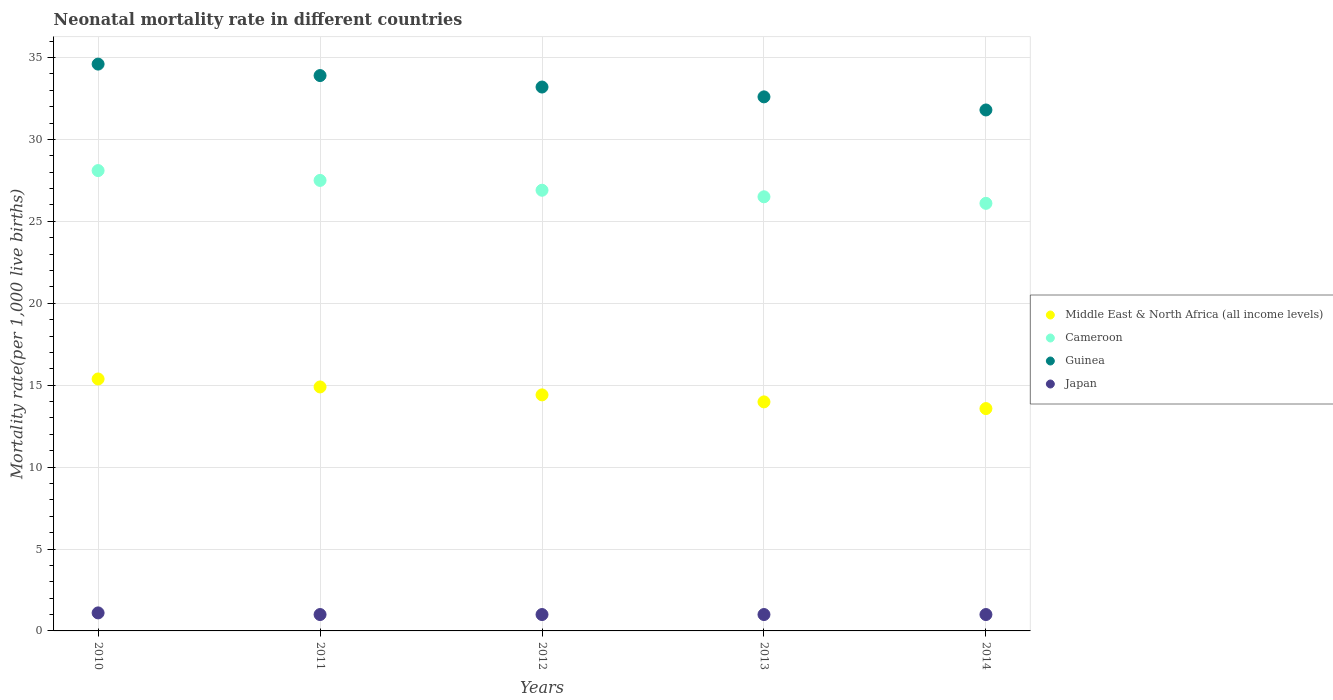Is the number of dotlines equal to the number of legend labels?
Offer a terse response. Yes. What is the neonatal mortality rate in Cameroon in 2010?
Provide a short and direct response. 28.1. Across all years, what is the maximum neonatal mortality rate in Cameroon?
Provide a succinct answer. 28.1. Across all years, what is the minimum neonatal mortality rate in Middle East & North Africa (all income levels)?
Your answer should be compact. 13.57. In which year was the neonatal mortality rate in Guinea minimum?
Give a very brief answer. 2014. What is the total neonatal mortality rate in Guinea in the graph?
Offer a very short reply. 166.1. What is the difference between the neonatal mortality rate in Guinea in 2010 and that in 2012?
Ensure brevity in your answer.  1.4. What is the difference between the neonatal mortality rate in Cameroon in 2014 and the neonatal mortality rate in Middle East & North Africa (all income levels) in 2010?
Your response must be concise. 10.72. What is the average neonatal mortality rate in Guinea per year?
Provide a succinct answer. 33.22. In the year 2011, what is the difference between the neonatal mortality rate in Japan and neonatal mortality rate in Cameroon?
Offer a very short reply. -26.5. What is the ratio of the neonatal mortality rate in Cameroon in 2010 to that in 2011?
Provide a short and direct response. 1.02. Is the neonatal mortality rate in Japan in 2011 less than that in 2013?
Your answer should be compact. No. What is the difference between the highest and the second highest neonatal mortality rate in Cameroon?
Ensure brevity in your answer.  0.6. What is the difference between the highest and the lowest neonatal mortality rate in Japan?
Your answer should be compact. 0.1. In how many years, is the neonatal mortality rate in Middle East & North Africa (all income levels) greater than the average neonatal mortality rate in Middle East & North Africa (all income levels) taken over all years?
Offer a very short reply. 2. Is the sum of the neonatal mortality rate in Guinea in 2010 and 2011 greater than the maximum neonatal mortality rate in Japan across all years?
Give a very brief answer. Yes. Is it the case that in every year, the sum of the neonatal mortality rate in Japan and neonatal mortality rate in Guinea  is greater than the sum of neonatal mortality rate in Cameroon and neonatal mortality rate in Middle East & North Africa (all income levels)?
Keep it short and to the point. No. Is it the case that in every year, the sum of the neonatal mortality rate in Guinea and neonatal mortality rate in Japan  is greater than the neonatal mortality rate in Cameroon?
Ensure brevity in your answer.  Yes. How many years are there in the graph?
Give a very brief answer. 5. What is the difference between two consecutive major ticks on the Y-axis?
Your answer should be compact. 5. Are the values on the major ticks of Y-axis written in scientific E-notation?
Your answer should be compact. No. Does the graph contain any zero values?
Your answer should be very brief. No. Where does the legend appear in the graph?
Offer a very short reply. Center right. What is the title of the graph?
Offer a very short reply. Neonatal mortality rate in different countries. What is the label or title of the X-axis?
Give a very brief answer. Years. What is the label or title of the Y-axis?
Your answer should be compact. Mortality rate(per 1,0 live births). What is the Mortality rate(per 1,000 live births) of Middle East & North Africa (all income levels) in 2010?
Your answer should be compact. 15.38. What is the Mortality rate(per 1,000 live births) of Cameroon in 2010?
Keep it short and to the point. 28.1. What is the Mortality rate(per 1,000 live births) in Guinea in 2010?
Offer a terse response. 34.6. What is the Mortality rate(per 1,000 live births) of Japan in 2010?
Give a very brief answer. 1.1. What is the Mortality rate(per 1,000 live births) in Middle East & North Africa (all income levels) in 2011?
Provide a short and direct response. 14.89. What is the Mortality rate(per 1,000 live births) of Cameroon in 2011?
Give a very brief answer. 27.5. What is the Mortality rate(per 1,000 live births) in Guinea in 2011?
Provide a short and direct response. 33.9. What is the Mortality rate(per 1,000 live births) in Middle East & North Africa (all income levels) in 2012?
Make the answer very short. 14.41. What is the Mortality rate(per 1,000 live births) of Cameroon in 2012?
Offer a very short reply. 26.9. What is the Mortality rate(per 1,000 live births) of Guinea in 2012?
Offer a terse response. 33.2. What is the Mortality rate(per 1,000 live births) of Japan in 2012?
Keep it short and to the point. 1. What is the Mortality rate(per 1,000 live births) in Middle East & North Africa (all income levels) in 2013?
Keep it short and to the point. 13.98. What is the Mortality rate(per 1,000 live births) of Cameroon in 2013?
Make the answer very short. 26.5. What is the Mortality rate(per 1,000 live births) of Guinea in 2013?
Ensure brevity in your answer.  32.6. What is the Mortality rate(per 1,000 live births) in Middle East & North Africa (all income levels) in 2014?
Give a very brief answer. 13.57. What is the Mortality rate(per 1,000 live births) of Cameroon in 2014?
Make the answer very short. 26.1. What is the Mortality rate(per 1,000 live births) in Guinea in 2014?
Offer a very short reply. 31.8. Across all years, what is the maximum Mortality rate(per 1,000 live births) of Middle East & North Africa (all income levels)?
Your answer should be very brief. 15.38. Across all years, what is the maximum Mortality rate(per 1,000 live births) of Cameroon?
Offer a terse response. 28.1. Across all years, what is the maximum Mortality rate(per 1,000 live births) in Guinea?
Your answer should be compact. 34.6. Across all years, what is the minimum Mortality rate(per 1,000 live births) in Middle East & North Africa (all income levels)?
Offer a very short reply. 13.57. Across all years, what is the minimum Mortality rate(per 1,000 live births) in Cameroon?
Offer a very short reply. 26.1. Across all years, what is the minimum Mortality rate(per 1,000 live births) in Guinea?
Offer a very short reply. 31.8. What is the total Mortality rate(per 1,000 live births) in Middle East & North Africa (all income levels) in the graph?
Provide a short and direct response. 72.23. What is the total Mortality rate(per 1,000 live births) of Cameroon in the graph?
Make the answer very short. 135.1. What is the total Mortality rate(per 1,000 live births) in Guinea in the graph?
Your answer should be very brief. 166.1. What is the difference between the Mortality rate(per 1,000 live births) in Middle East & North Africa (all income levels) in 2010 and that in 2011?
Provide a short and direct response. 0.49. What is the difference between the Mortality rate(per 1,000 live births) of Japan in 2010 and that in 2011?
Make the answer very short. 0.1. What is the difference between the Mortality rate(per 1,000 live births) of Middle East & North Africa (all income levels) in 2010 and that in 2012?
Your answer should be compact. 0.97. What is the difference between the Mortality rate(per 1,000 live births) in Japan in 2010 and that in 2012?
Ensure brevity in your answer.  0.1. What is the difference between the Mortality rate(per 1,000 live births) in Middle East & North Africa (all income levels) in 2010 and that in 2013?
Ensure brevity in your answer.  1.4. What is the difference between the Mortality rate(per 1,000 live births) of Japan in 2010 and that in 2013?
Your response must be concise. 0.1. What is the difference between the Mortality rate(per 1,000 live births) in Middle East & North Africa (all income levels) in 2010 and that in 2014?
Ensure brevity in your answer.  1.81. What is the difference between the Mortality rate(per 1,000 live births) in Cameroon in 2010 and that in 2014?
Provide a succinct answer. 2. What is the difference between the Mortality rate(per 1,000 live births) of Middle East & North Africa (all income levels) in 2011 and that in 2012?
Ensure brevity in your answer.  0.48. What is the difference between the Mortality rate(per 1,000 live births) in Guinea in 2011 and that in 2012?
Give a very brief answer. 0.7. What is the difference between the Mortality rate(per 1,000 live births) in Japan in 2011 and that in 2012?
Provide a succinct answer. 0. What is the difference between the Mortality rate(per 1,000 live births) of Middle East & North Africa (all income levels) in 2011 and that in 2013?
Your answer should be compact. 0.91. What is the difference between the Mortality rate(per 1,000 live births) in Guinea in 2011 and that in 2013?
Give a very brief answer. 1.3. What is the difference between the Mortality rate(per 1,000 live births) in Middle East & North Africa (all income levels) in 2011 and that in 2014?
Your answer should be compact. 1.32. What is the difference between the Mortality rate(per 1,000 live births) in Cameroon in 2011 and that in 2014?
Your answer should be compact. 1.4. What is the difference between the Mortality rate(per 1,000 live births) in Japan in 2011 and that in 2014?
Offer a terse response. 0. What is the difference between the Mortality rate(per 1,000 live births) of Middle East & North Africa (all income levels) in 2012 and that in 2013?
Keep it short and to the point. 0.43. What is the difference between the Mortality rate(per 1,000 live births) of Guinea in 2012 and that in 2013?
Your response must be concise. 0.6. What is the difference between the Mortality rate(per 1,000 live births) in Middle East & North Africa (all income levels) in 2012 and that in 2014?
Make the answer very short. 0.84. What is the difference between the Mortality rate(per 1,000 live births) in Guinea in 2012 and that in 2014?
Your answer should be very brief. 1.4. What is the difference between the Mortality rate(per 1,000 live births) of Middle East & North Africa (all income levels) in 2013 and that in 2014?
Your answer should be very brief. 0.41. What is the difference between the Mortality rate(per 1,000 live births) in Japan in 2013 and that in 2014?
Your answer should be compact. 0. What is the difference between the Mortality rate(per 1,000 live births) of Middle East & North Africa (all income levels) in 2010 and the Mortality rate(per 1,000 live births) of Cameroon in 2011?
Your response must be concise. -12.12. What is the difference between the Mortality rate(per 1,000 live births) of Middle East & North Africa (all income levels) in 2010 and the Mortality rate(per 1,000 live births) of Guinea in 2011?
Your response must be concise. -18.52. What is the difference between the Mortality rate(per 1,000 live births) in Middle East & North Africa (all income levels) in 2010 and the Mortality rate(per 1,000 live births) in Japan in 2011?
Your answer should be very brief. 14.38. What is the difference between the Mortality rate(per 1,000 live births) in Cameroon in 2010 and the Mortality rate(per 1,000 live births) in Japan in 2011?
Your answer should be very brief. 27.1. What is the difference between the Mortality rate(per 1,000 live births) in Guinea in 2010 and the Mortality rate(per 1,000 live births) in Japan in 2011?
Keep it short and to the point. 33.6. What is the difference between the Mortality rate(per 1,000 live births) in Middle East & North Africa (all income levels) in 2010 and the Mortality rate(per 1,000 live births) in Cameroon in 2012?
Your answer should be compact. -11.52. What is the difference between the Mortality rate(per 1,000 live births) of Middle East & North Africa (all income levels) in 2010 and the Mortality rate(per 1,000 live births) of Guinea in 2012?
Offer a very short reply. -17.82. What is the difference between the Mortality rate(per 1,000 live births) of Middle East & North Africa (all income levels) in 2010 and the Mortality rate(per 1,000 live births) of Japan in 2012?
Offer a terse response. 14.38. What is the difference between the Mortality rate(per 1,000 live births) in Cameroon in 2010 and the Mortality rate(per 1,000 live births) in Japan in 2012?
Ensure brevity in your answer.  27.1. What is the difference between the Mortality rate(per 1,000 live births) in Guinea in 2010 and the Mortality rate(per 1,000 live births) in Japan in 2012?
Your answer should be compact. 33.6. What is the difference between the Mortality rate(per 1,000 live births) of Middle East & North Africa (all income levels) in 2010 and the Mortality rate(per 1,000 live births) of Cameroon in 2013?
Provide a short and direct response. -11.12. What is the difference between the Mortality rate(per 1,000 live births) in Middle East & North Africa (all income levels) in 2010 and the Mortality rate(per 1,000 live births) in Guinea in 2013?
Your answer should be very brief. -17.22. What is the difference between the Mortality rate(per 1,000 live births) of Middle East & North Africa (all income levels) in 2010 and the Mortality rate(per 1,000 live births) of Japan in 2013?
Make the answer very short. 14.38. What is the difference between the Mortality rate(per 1,000 live births) of Cameroon in 2010 and the Mortality rate(per 1,000 live births) of Guinea in 2013?
Offer a very short reply. -4.5. What is the difference between the Mortality rate(per 1,000 live births) in Cameroon in 2010 and the Mortality rate(per 1,000 live births) in Japan in 2013?
Give a very brief answer. 27.1. What is the difference between the Mortality rate(per 1,000 live births) of Guinea in 2010 and the Mortality rate(per 1,000 live births) of Japan in 2013?
Offer a terse response. 33.6. What is the difference between the Mortality rate(per 1,000 live births) in Middle East & North Africa (all income levels) in 2010 and the Mortality rate(per 1,000 live births) in Cameroon in 2014?
Make the answer very short. -10.72. What is the difference between the Mortality rate(per 1,000 live births) in Middle East & North Africa (all income levels) in 2010 and the Mortality rate(per 1,000 live births) in Guinea in 2014?
Offer a terse response. -16.42. What is the difference between the Mortality rate(per 1,000 live births) in Middle East & North Africa (all income levels) in 2010 and the Mortality rate(per 1,000 live births) in Japan in 2014?
Your answer should be very brief. 14.38. What is the difference between the Mortality rate(per 1,000 live births) of Cameroon in 2010 and the Mortality rate(per 1,000 live births) of Japan in 2014?
Keep it short and to the point. 27.1. What is the difference between the Mortality rate(per 1,000 live births) in Guinea in 2010 and the Mortality rate(per 1,000 live births) in Japan in 2014?
Keep it short and to the point. 33.6. What is the difference between the Mortality rate(per 1,000 live births) of Middle East & North Africa (all income levels) in 2011 and the Mortality rate(per 1,000 live births) of Cameroon in 2012?
Make the answer very short. -12.01. What is the difference between the Mortality rate(per 1,000 live births) in Middle East & North Africa (all income levels) in 2011 and the Mortality rate(per 1,000 live births) in Guinea in 2012?
Make the answer very short. -18.31. What is the difference between the Mortality rate(per 1,000 live births) in Middle East & North Africa (all income levels) in 2011 and the Mortality rate(per 1,000 live births) in Japan in 2012?
Give a very brief answer. 13.89. What is the difference between the Mortality rate(per 1,000 live births) of Cameroon in 2011 and the Mortality rate(per 1,000 live births) of Japan in 2012?
Ensure brevity in your answer.  26.5. What is the difference between the Mortality rate(per 1,000 live births) in Guinea in 2011 and the Mortality rate(per 1,000 live births) in Japan in 2012?
Offer a very short reply. 32.9. What is the difference between the Mortality rate(per 1,000 live births) in Middle East & North Africa (all income levels) in 2011 and the Mortality rate(per 1,000 live births) in Cameroon in 2013?
Offer a terse response. -11.61. What is the difference between the Mortality rate(per 1,000 live births) of Middle East & North Africa (all income levels) in 2011 and the Mortality rate(per 1,000 live births) of Guinea in 2013?
Provide a short and direct response. -17.71. What is the difference between the Mortality rate(per 1,000 live births) of Middle East & North Africa (all income levels) in 2011 and the Mortality rate(per 1,000 live births) of Japan in 2013?
Make the answer very short. 13.89. What is the difference between the Mortality rate(per 1,000 live births) in Cameroon in 2011 and the Mortality rate(per 1,000 live births) in Guinea in 2013?
Your response must be concise. -5.1. What is the difference between the Mortality rate(per 1,000 live births) in Cameroon in 2011 and the Mortality rate(per 1,000 live births) in Japan in 2013?
Provide a succinct answer. 26.5. What is the difference between the Mortality rate(per 1,000 live births) of Guinea in 2011 and the Mortality rate(per 1,000 live births) of Japan in 2013?
Give a very brief answer. 32.9. What is the difference between the Mortality rate(per 1,000 live births) in Middle East & North Africa (all income levels) in 2011 and the Mortality rate(per 1,000 live births) in Cameroon in 2014?
Make the answer very short. -11.21. What is the difference between the Mortality rate(per 1,000 live births) of Middle East & North Africa (all income levels) in 2011 and the Mortality rate(per 1,000 live births) of Guinea in 2014?
Provide a short and direct response. -16.91. What is the difference between the Mortality rate(per 1,000 live births) in Middle East & North Africa (all income levels) in 2011 and the Mortality rate(per 1,000 live births) in Japan in 2014?
Your response must be concise. 13.89. What is the difference between the Mortality rate(per 1,000 live births) in Cameroon in 2011 and the Mortality rate(per 1,000 live births) in Guinea in 2014?
Provide a short and direct response. -4.3. What is the difference between the Mortality rate(per 1,000 live births) of Cameroon in 2011 and the Mortality rate(per 1,000 live births) of Japan in 2014?
Provide a succinct answer. 26.5. What is the difference between the Mortality rate(per 1,000 live births) in Guinea in 2011 and the Mortality rate(per 1,000 live births) in Japan in 2014?
Provide a succinct answer. 32.9. What is the difference between the Mortality rate(per 1,000 live births) in Middle East & North Africa (all income levels) in 2012 and the Mortality rate(per 1,000 live births) in Cameroon in 2013?
Ensure brevity in your answer.  -12.09. What is the difference between the Mortality rate(per 1,000 live births) of Middle East & North Africa (all income levels) in 2012 and the Mortality rate(per 1,000 live births) of Guinea in 2013?
Offer a very short reply. -18.19. What is the difference between the Mortality rate(per 1,000 live births) of Middle East & North Africa (all income levels) in 2012 and the Mortality rate(per 1,000 live births) of Japan in 2013?
Give a very brief answer. 13.41. What is the difference between the Mortality rate(per 1,000 live births) of Cameroon in 2012 and the Mortality rate(per 1,000 live births) of Guinea in 2013?
Your answer should be compact. -5.7. What is the difference between the Mortality rate(per 1,000 live births) in Cameroon in 2012 and the Mortality rate(per 1,000 live births) in Japan in 2013?
Make the answer very short. 25.9. What is the difference between the Mortality rate(per 1,000 live births) in Guinea in 2012 and the Mortality rate(per 1,000 live births) in Japan in 2013?
Provide a short and direct response. 32.2. What is the difference between the Mortality rate(per 1,000 live births) in Middle East & North Africa (all income levels) in 2012 and the Mortality rate(per 1,000 live births) in Cameroon in 2014?
Your answer should be very brief. -11.69. What is the difference between the Mortality rate(per 1,000 live births) in Middle East & North Africa (all income levels) in 2012 and the Mortality rate(per 1,000 live births) in Guinea in 2014?
Offer a terse response. -17.39. What is the difference between the Mortality rate(per 1,000 live births) of Middle East & North Africa (all income levels) in 2012 and the Mortality rate(per 1,000 live births) of Japan in 2014?
Offer a terse response. 13.41. What is the difference between the Mortality rate(per 1,000 live births) of Cameroon in 2012 and the Mortality rate(per 1,000 live births) of Japan in 2014?
Your response must be concise. 25.9. What is the difference between the Mortality rate(per 1,000 live births) in Guinea in 2012 and the Mortality rate(per 1,000 live births) in Japan in 2014?
Offer a very short reply. 32.2. What is the difference between the Mortality rate(per 1,000 live births) in Middle East & North Africa (all income levels) in 2013 and the Mortality rate(per 1,000 live births) in Cameroon in 2014?
Offer a terse response. -12.12. What is the difference between the Mortality rate(per 1,000 live births) of Middle East & North Africa (all income levels) in 2013 and the Mortality rate(per 1,000 live births) of Guinea in 2014?
Provide a short and direct response. -17.82. What is the difference between the Mortality rate(per 1,000 live births) of Middle East & North Africa (all income levels) in 2013 and the Mortality rate(per 1,000 live births) of Japan in 2014?
Offer a very short reply. 12.98. What is the difference between the Mortality rate(per 1,000 live births) in Cameroon in 2013 and the Mortality rate(per 1,000 live births) in Japan in 2014?
Offer a very short reply. 25.5. What is the difference between the Mortality rate(per 1,000 live births) in Guinea in 2013 and the Mortality rate(per 1,000 live births) in Japan in 2014?
Offer a very short reply. 31.6. What is the average Mortality rate(per 1,000 live births) in Middle East & North Africa (all income levels) per year?
Provide a short and direct response. 14.45. What is the average Mortality rate(per 1,000 live births) of Cameroon per year?
Your response must be concise. 27.02. What is the average Mortality rate(per 1,000 live births) of Guinea per year?
Make the answer very short. 33.22. What is the average Mortality rate(per 1,000 live births) in Japan per year?
Offer a terse response. 1.02. In the year 2010, what is the difference between the Mortality rate(per 1,000 live births) of Middle East & North Africa (all income levels) and Mortality rate(per 1,000 live births) of Cameroon?
Make the answer very short. -12.72. In the year 2010, what is the difference between the Mortality rate(per 1,000 live births) of Middle East & North Africa (all income levels) and Mortality rate(per 1,000 live births) of Guinea?
Keep it short and to the point. -19.22. In the year 2010, what is the difference between the Mortality rate(per 1,000 live births) in Middle East & North Africa (all income levels) and Mortality rate(per 1,000 live births) in Japan?
Offer a very short reply. 14.28. In the year 2010, what is the difference between the Mortality rate(per 1,000 live births) of Cameroon and Mortality rate(per 1,000 live births) of Japan?
Ensure brevity in your answer.  27. In the year 2010, what is the difference between the Mortality rate(per 1,000 live births) of Guinea and Mortality rate(per 1,000 live births) of Japan?
Give a very brief answer. 33.5. In the year 2011, what is the difference between the Mortality rate(per 1,000 live births) in Middle East & North Africa (all income levels) and Mortality rate(per 1,000 live births) in Cameroon?
Offer a terse response. -12.61. In the year 2011, what is the difference between the Mortality rate(per 1,000 live births) in Middle East & North Africa (all income levels) and Mortality rate(per 1,000 live births) in Guinea?
Your response must be concise. -19.01. In the year 2011, what is the difference between the Mortality rate(per 1,000 live births) in Middle East & North Africa (all income levels) and Mortality rate(per 1,000 live births) in Japan?
Your answer should be very brief. 13.89. In the year 2011, what is the difference between the Mortality rate(per 1,000 live births) in Cameroon and Mortality rate(per 1,000 live births) in Japan?
Offer a very short reply. 26.5. In the year 2011, what is the difference between the Mortality rate(per 1,000 live births) in Guinea and Mortality rate(per 1,000 live births) in Japan?
Your response must be concise. 32.9. In the year 2012, what is the difference between the Mortality rate(per 1,000 live births) of Middle East & North Africa (all income levels) and Mortality rate(per 1,000 live births) of Cameroon?
Provide a short and direct response. -12.49. In the year 2012, what is the difference between the Mortality rate(per 1,000 live births) of Middle East & North Africa (all income levels) and Mortality rate(per 1,000 live births) of Guinea?
Keep it short and to the point. -18.79. In the year 2012, what is the difference between the Mortality rate(per 1,000 live births) in Middle East & North Africa (all income levels) and Mortality rate(per 1,000 live births) in Japan?
Your answer should be very brief. 13.41. In the year 2012, what is the difference between the Mortality rate(per 1,000 live births) in Cameroon and Mortality rate(per 1,000 live births) in Japan?
Make the answer very short. 25.9. In the year 2012, what is the difference between the Mortality rate(per 1,000 live births) of Guinea and Mortality rate(per 1,000 live births) of Japan?
Offer a terse response. 32.2. In the year 2013, what is the difference between the Mortality rate(per 1,000 live births) in Middle East & North Africa (all income levels) and Mortality rate(per 1,000 live births) in Cameroon?
Give a very brief answer. -12.52. In the year 2013, what is the difference between the Mortality rate(per 1,000 live births) in Middle East & North Africa (all income levels) and Mortality rate(per 1,000 live births) in Guinea?
Your response must be concise. -18.62. In the year 2013, what is the difference between the Mortality rate(per 1,000 live births) in Middle East & North Africa (all income levels) and Mortality rate(per 1,000 live births) in Japan?
Make the answer very short. 12.98. In the year 2013, what is the difference between the Mortality rate(per 1,000 live births) of Cameroon and Mortality rate(per 1,000 live births) of Guinea?
Your response must be concise. -6.1. In the year 2013, what is the difference between the Mortality rate(per 1,000 live births) in Guinea and Mortality rate(per 1,000 live births) in Japan?
Offer a very short reply. 31.6. In the year 2014, what is the difference between the Mortality rate(per 1,000 live births) of Middle East & North Africa (all income levels) and Mortality rate(per 1,000 live births) of Cameroon?
Offer a very short reply. -12.53. In the year 2014, what is the difference between the Mortality rate(per 1,000 live births) in Middle East & North Africa (all income levels) and Mortality rate(per 1,000 live births) in Guinea?
Your answer should be compact. -18.23. In the year 2014, what is the difference between the Mortality rate(per 1,000 live births) in Middle East & North Africa (all income levels) and Mortality rate(per 1,000 live births) in Japan?
Offer a very short reply. 12.57. In the year 2014, what is the difference between the Mortality rate(per 1,000 live births) of Cameroon and Mortality rate(per 1,000 live births) of Guinea?
Offer a terse response. -5.7. In the year 2014, what is the difference between the Mortality rate(per 1,000 live births) of Cameroon and Mortality rate(per 1,000 live births) of Japan?
Make the answer very short. 25.1. In the year 2014, what is the difference between the Mortality rate(per 1,000 live births) of Guinea and Mortality rate(per 1,000 live births) of Japan?
Provide a succinct answer. 30.8. What is the ratio of the Mortality rate(per 1,000 live births) in Middle East & North Africa (all income levels) in 2010 to that in 2011?
Ensure brevity in your answer.  1.03. What is the ratio of the Mortality rate(per 1,000 live births) in Cameroon in 2010 to that in 2011?
Your answer should be very brief. 1.02. What is the ratio of the Mortality rate(per 1,000 live births) in Guinea in 2010 to that in 2011?
Provide a short and direct response. 1.02. What is the ratio of the Mortality rate(per 1,000 live births) in Middle East & North Africa (all income levels) in 2010 to that in 2012?
Your answer should be compact. 1.07. What is the ratio of the Mortality rate(per 1,000 live births) of Cameroon in 2010 to that in 2012?
Your response must be concise. 1.04. What is the ratio of the Mortality rate(per 1,000 live births) in Guinea in 2010 to that in 2012?
Keep it short and to the point. 1.04. What is the ratio of the Mortality rate(per 1,000 live births) of Japan in 2010 to that in 2012?
Make the answer very short. 1.1. What is the ratio of the Mortality rate(per 1,000 live births) of Middle East & North Africa (all income levels) in 2010 to that in 2013?
Your response must be concise. 1.1. What is the ratio of the Mortality rate(per 1,000 live births) of Cameroon in 2010 to that in 2013?
Your response must be concise. 1.06. What is the ratio of the Mortality rate(per 1,000 live births) of Guinea in 2010 to that in 2013?
Give a very brief answer. 1.06. What is the ratio of the Mortality rate(per 1,000 live births) in Japan in 2010 to that in 2013?
Provide a succinct answer. 1.1. What is the ratio of the Mortality rate(per 1,000 live births) in Middle East & North Africa (all income levels) in 2010 to that in 2014?
Provide a short and direct response. 1.13. What is the ratio of the Mortality rate(per 1,000 live births) in Cameroon in 2010 to that in 2014?
Offer a very short reply. 1.08. What is the ratio of the Mortality rate(per 1,000 live births) in Guinea in 2010 to that in 2014?
Provide a succinct answer. 1.09. What is the ratio of the Mortality rate(per 1,000 live births) of Middle East & North Africa (all income levels) in 2011 to that in 2012?
Keep it short and to the point. 1.03. What is the ratio of the Mortality rate(per 1,000 live births) in Cameroon in 2011 to that in 2012?
Provide a succinct answer. 1.02. What is the ratio of the Mortality rate(per 1,000 live births) of Guinea in 2011 to that in 2012?
Offer a terse response. 1.02. What is the ratio of the Mortality rate(per 1,000 live births) in Middle East & North Africa (all income levels) in 2011 to that in 2013?
Your response must be concise. 1.07. What is the ratio of the Mortality rate(per 1,000 live births) in Cameroon in 2011 to that in 2013?
Make the answer very short. 1.04. What is the ratio of the Mortality rate(per 1,000 live births) of Guinea in 2011 to that in 2013?
Your response must be concise. 1.04. What is the ratio of the Mortality rate(per 1,000 live births) of Japan in 2011 to that in 2013?
Provide a short and direct response. 1. What is the ratio of the Mortality rate(per 1,000 live births) in Middle East & North Africa (all income levels) in 2011 to that in 2014?
Keep it short and to the point. 1.1. What is the ratio of the Mortality rate(per 1,000 live births) of Cameroon in 2011 to that in 2014?
Provide a short and direct response. 1.05. What is the ratio of the Mortality rate(per 1,000 live births) of Guinea in 2011 to that in 2014?
Your response must be concise. 1.07. What is the ratio of the Mortality rate(per 1,000 live births) of Middle East & North Africa (all income levels) in 2012 to that in 2013?
Give a very brief answer. 1.03. What is the ratio of the Mortality rate(per 1,000 live births) in Cameroon in 2012 to that in 2013?
Make the answer very short. 1.02. What is the ratio of the Mortality rate(per 1,000 live births) in Guinea in 2012 to that in 2013?
Your answer should be very brief. 1.02. What is the ratio of the Mortality rate(per 1,000 live births) of Middle East & North Africa (all income levels) in 2012 to that in 2014?
Provide a short and direct response. 1.06. What is the ratio of the Mortality rate(per 1,000 live births) of Cameroon in 2012 to that in 2014?
Make the answer very short. 1.03. What is the ratio of the Mortality rate(per 1,000 live births) of Guinea in 2012 to that in 2014?
Your answer should be compact. 1.04. What is the ratio of the Mortality rate(per 1,000 live births) of Japan in 2012 to that in 2014?
Ensure brevity in your answer.  1. What is the ratio of the Mortality rate(per 1,000 live births) in Middle East & North Africa (all income levels) in 2013 to that in 2014?
Offer a very short reply. 1.03. What is the ratio of the Mortality rate(per 1,000 live births) in Cameroon in 2013 to that in 2014?
Your response must be concise. 1.02. What is the ratio of the Mortality rate(per 1,000 live births) of Guinea in 2013 to that in 2014?
Provide a succinct answer. 1.03. What is the ratio of the Mortality rate(per 1,000 live births) of Japan in 2013 to that in 2014?
Ensure brevity in your answer.  1. What is the difference between the highest and the second highest Mortality rate(per 1,000 live births) of Middle East & North Africa (all income levels)?
Offer a terse response. 0.49. What is the difference between the highest and the lowest Mortality rate(per 1,000 live births) in Middle East & North Africa (all income levels)?
Your answer should be compact. 1.81. 